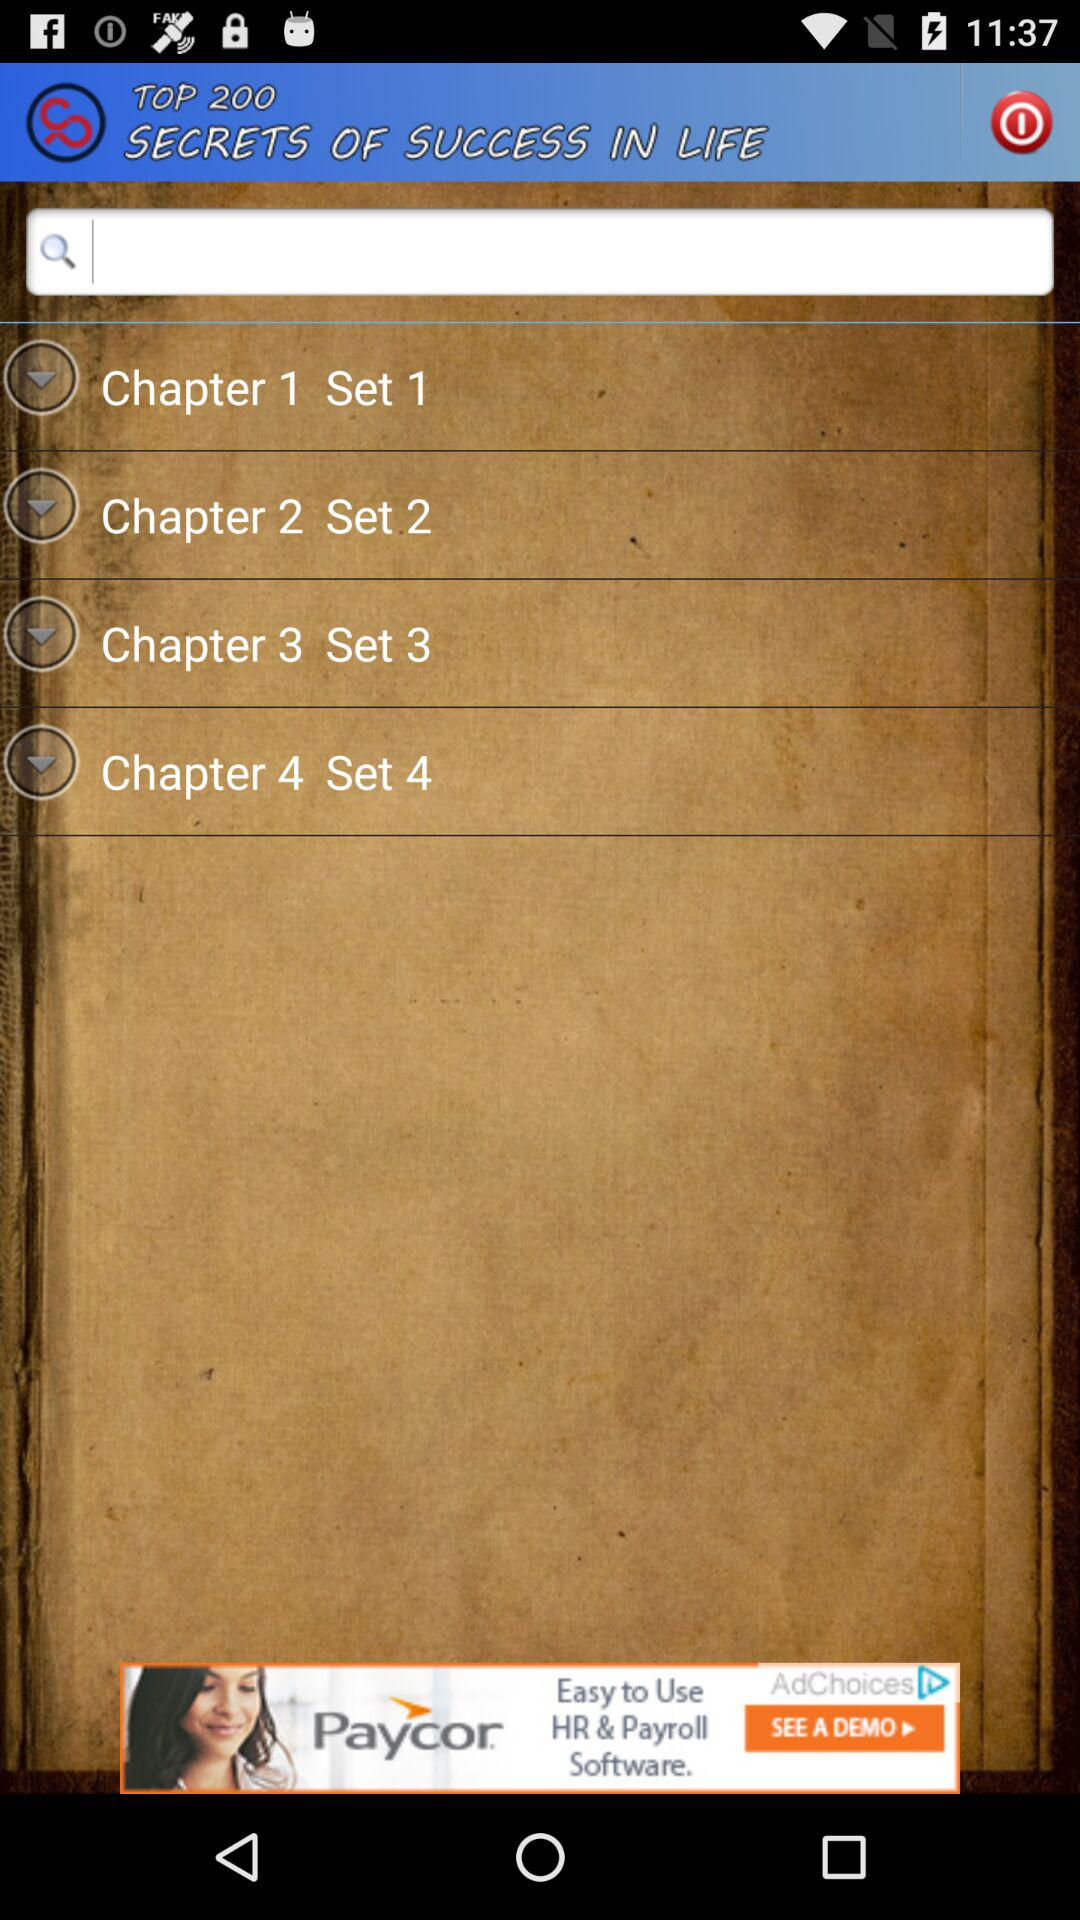What is the set number of Chapter 4? The set number for Chapter 4 is 4. 